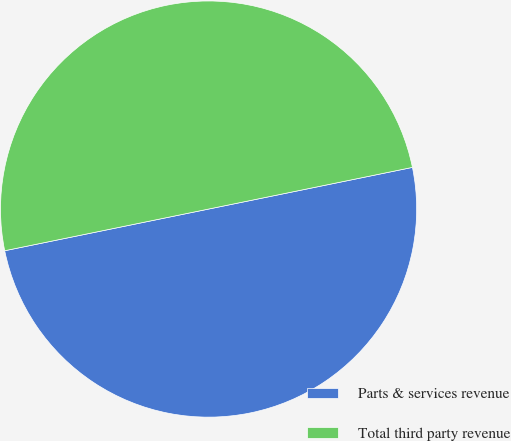Convert chart to OTSL. <chart><loc_0><loc_0><loc_500><loc_500><pie_chart><fcel>Parts & services revenue<fcel>Total third party revenue<nl><fcel>50.0%<fcel>50.0%<nl></chart> 